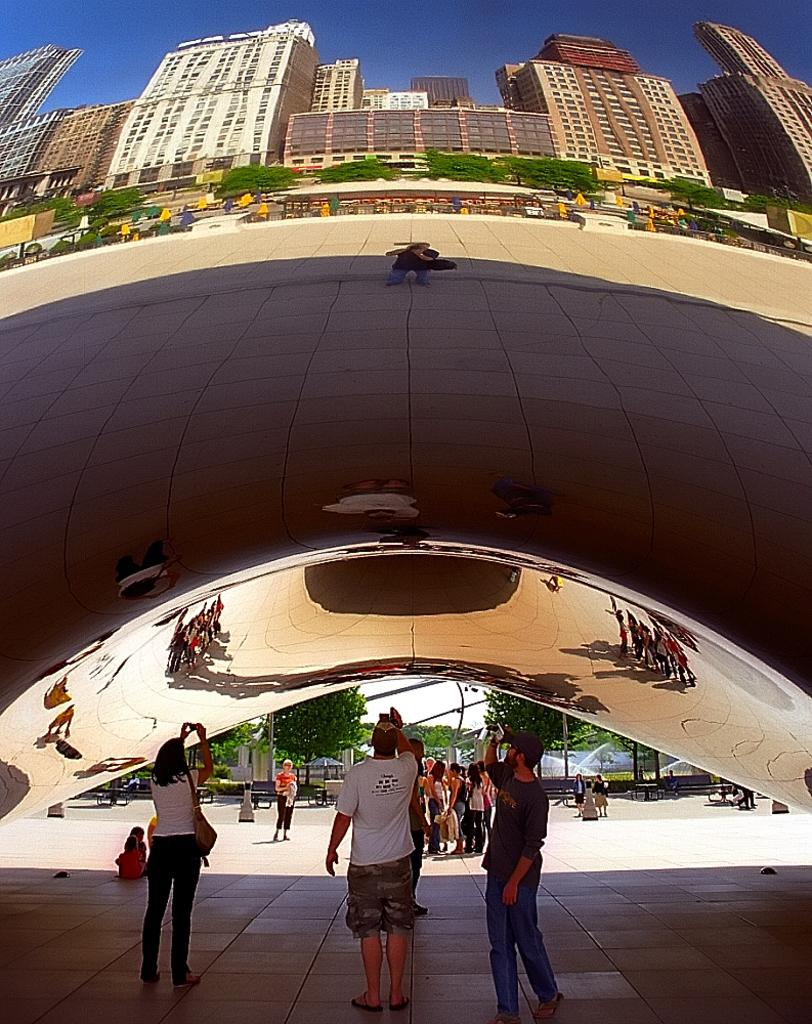What is the main structure in the image? There is a cloud gate in the image. Who or what can be seen in the image besides the cloud gate? There are people and buildings in the image. What other natural elements are present in the image? There are trees in the image. What can be seen in the background of the image? The sky is visible in the image. How many cattle are grazing near the cloud gate in the image? There are no cattle present in the image. What type of trip is being taken by the people in the image? The image does not provide information about any trip being taken by the people. 